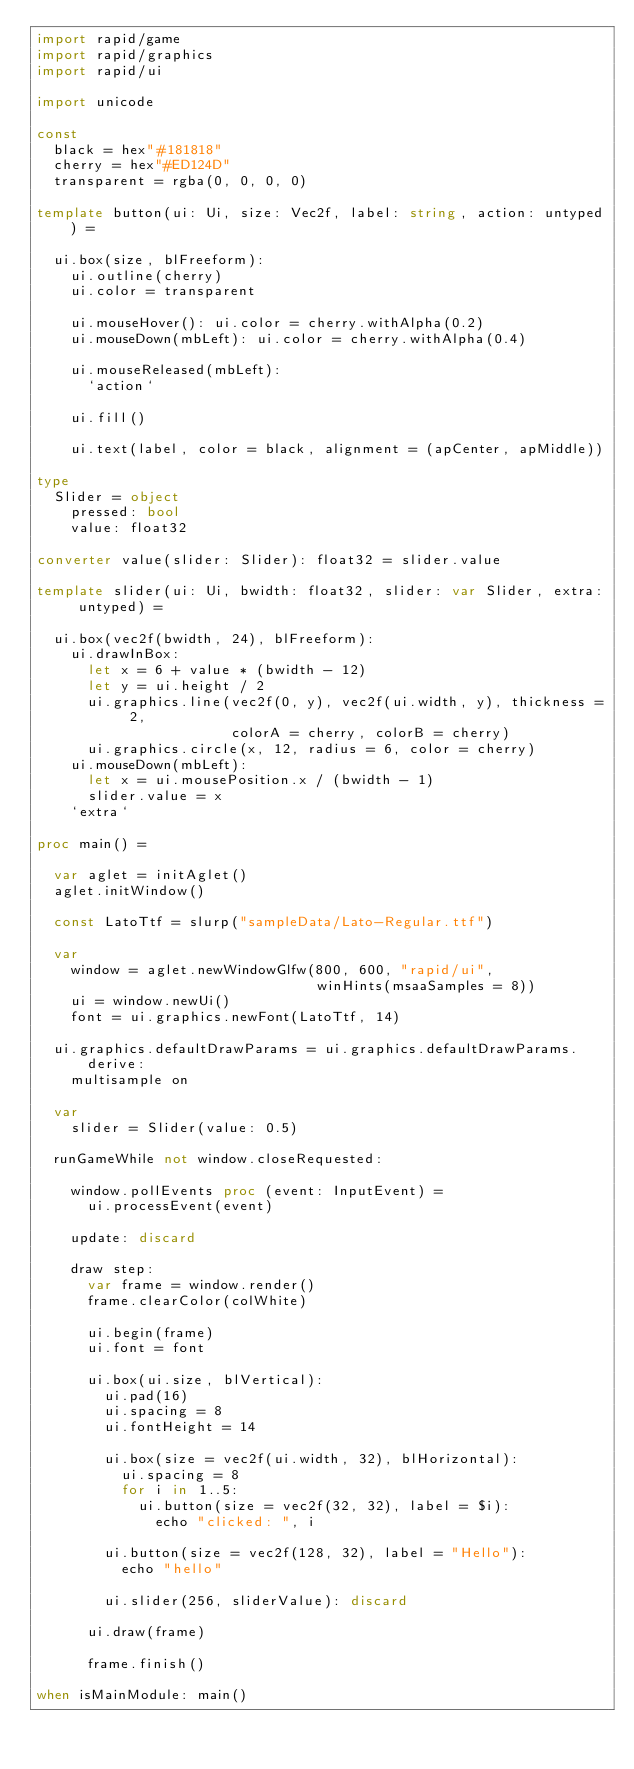Convert code to text. <code><loc_0><loc_0><loc_500><loc_500><_Nim_>import rapid/game
import rapid/graphics
import rapid/ui

import unicode

const
  black = hex"#181818"
  cherry = hex"#ED124D"
  transparent = rgba(0, 0, 0, 0)

template button(ui: Ui, size: Vec2f, label: string, action: untyped) =

  ui.box(size, blFreeform):
    ui.outline(cherry)
    ui.color = transparent

    ui.mouseHover(): ui.color = cherry.withAlpha(0.2)
    ui.mouseDown(mbLeft): ui.color = cherry.withAlpha(0.4)

    ui.mouseReleased(mbLeft):
      `action`

    ui.fill()

    ui.text(label, color = black, alignment = (apCenter, apMiddle))

type
  Slider = object
    pressed: bool
    value: float32

converter value(slider: Slider): float32 = slider.value

template slider(ui: Ui, bwidth: float32, slider: var Slider, extra: untyped) =

  ui.box(vec2f(bwidth, 24), blFreeform):
    ui.drawInBox:
      let x = 6 + value * (bwidth - 12)
      let y = ui.height / 2
      ui.graphics.line(vec2f(0, y), vec2f(ui.width, y), thickness = 2,
                       colorA = cherry, colorB = cherry)
      ui.graphics.circle(x, 12, radius = 6, color = cherry)
    ui.mouseDown(mbLeft):
      let x = ui.mousePosition.x / (bwidth - 1)
      slider.value = x
    `extra`

proc main() =

  var aglet = initAglet()
  aglet.initWindow()

  const LatoTtf = slurp("sampleData/Lato-Regular.ttf")

  var
    window = aglet.newWindowGlfw(800, 600, "rapid/ui",
                                 winHints(msaaSamples = 8))
    ui = window.newUi()
    font = ui.graphics.newFont(LatoTtf, 14)

  ui.graphics.defaultDrawParams = ui.graphics.defaultDrawParams.derive:
    multisample on

  var
    slider = Slider(value: 0.5)

  runGameWhile not window.closeRequested:

    window.pollEvents proc (event: InputEvent) =
      ui.processEvent(event)

    update: discard

    draw step:
      var frame = window.render()
      frame.clearColor(colWhite)

      ui.begin(frame)
      ui.font = font

      ui.box(ui.size, blVertical):
        ui.pad(16)
        ui.spacing = 8
        ui.fontHeight = 14

        ui.box(size = vec2f(ui.width, 32), blHorizontal):
          ui.spacing = 8
          for i in 1..5:
            ui.button(size = vec2f(32, 32), label = $i):
              echo "clicked: ", i

        ui.button(size = vec2f(128, 32), label = "Hello"):
          echo "hello"

        ui.slider(256, sliderValue): discard

      ui.draw(frame)

      frame.finish()

when isMainModule: main()
</code> 